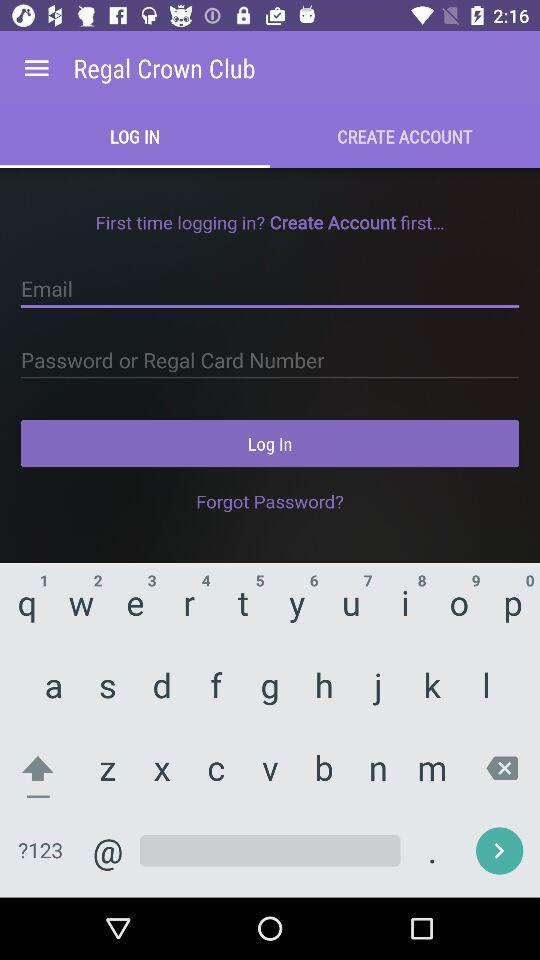Which tab am I on? You are on the "LOG IN" tab. 